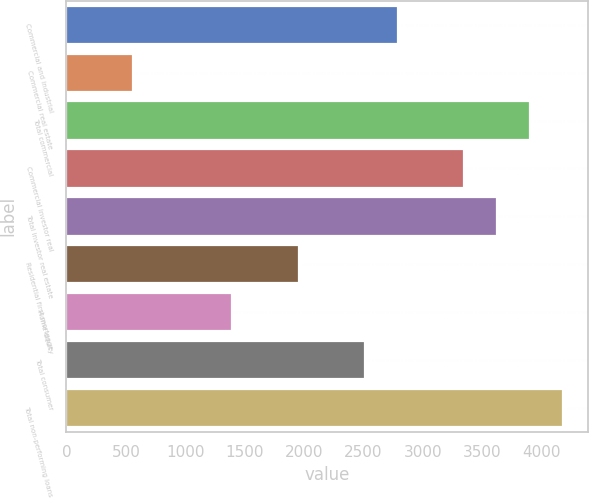Convert chart to OTSL. <chart><loc_0><loc_0><loc_500><loc_500><bar_chart><fcel>Commercial and industrial<fcel>Commercial real estate<fcel>Total commercial<fcel>Commercial investor real<fcel>Total investor real estate<fcel>Residential first mortgage<fcel>Home equity<fcel>Total consumer<fcel>Total non-performing loans<nl><fcel>2789<fcel>560.2<fcel>3903.4<fcel>3346.2<fcel>3624.8<fcel>1953.2<fcel>1396<fcel>2510.4<fcel>4182<nl></chart> 